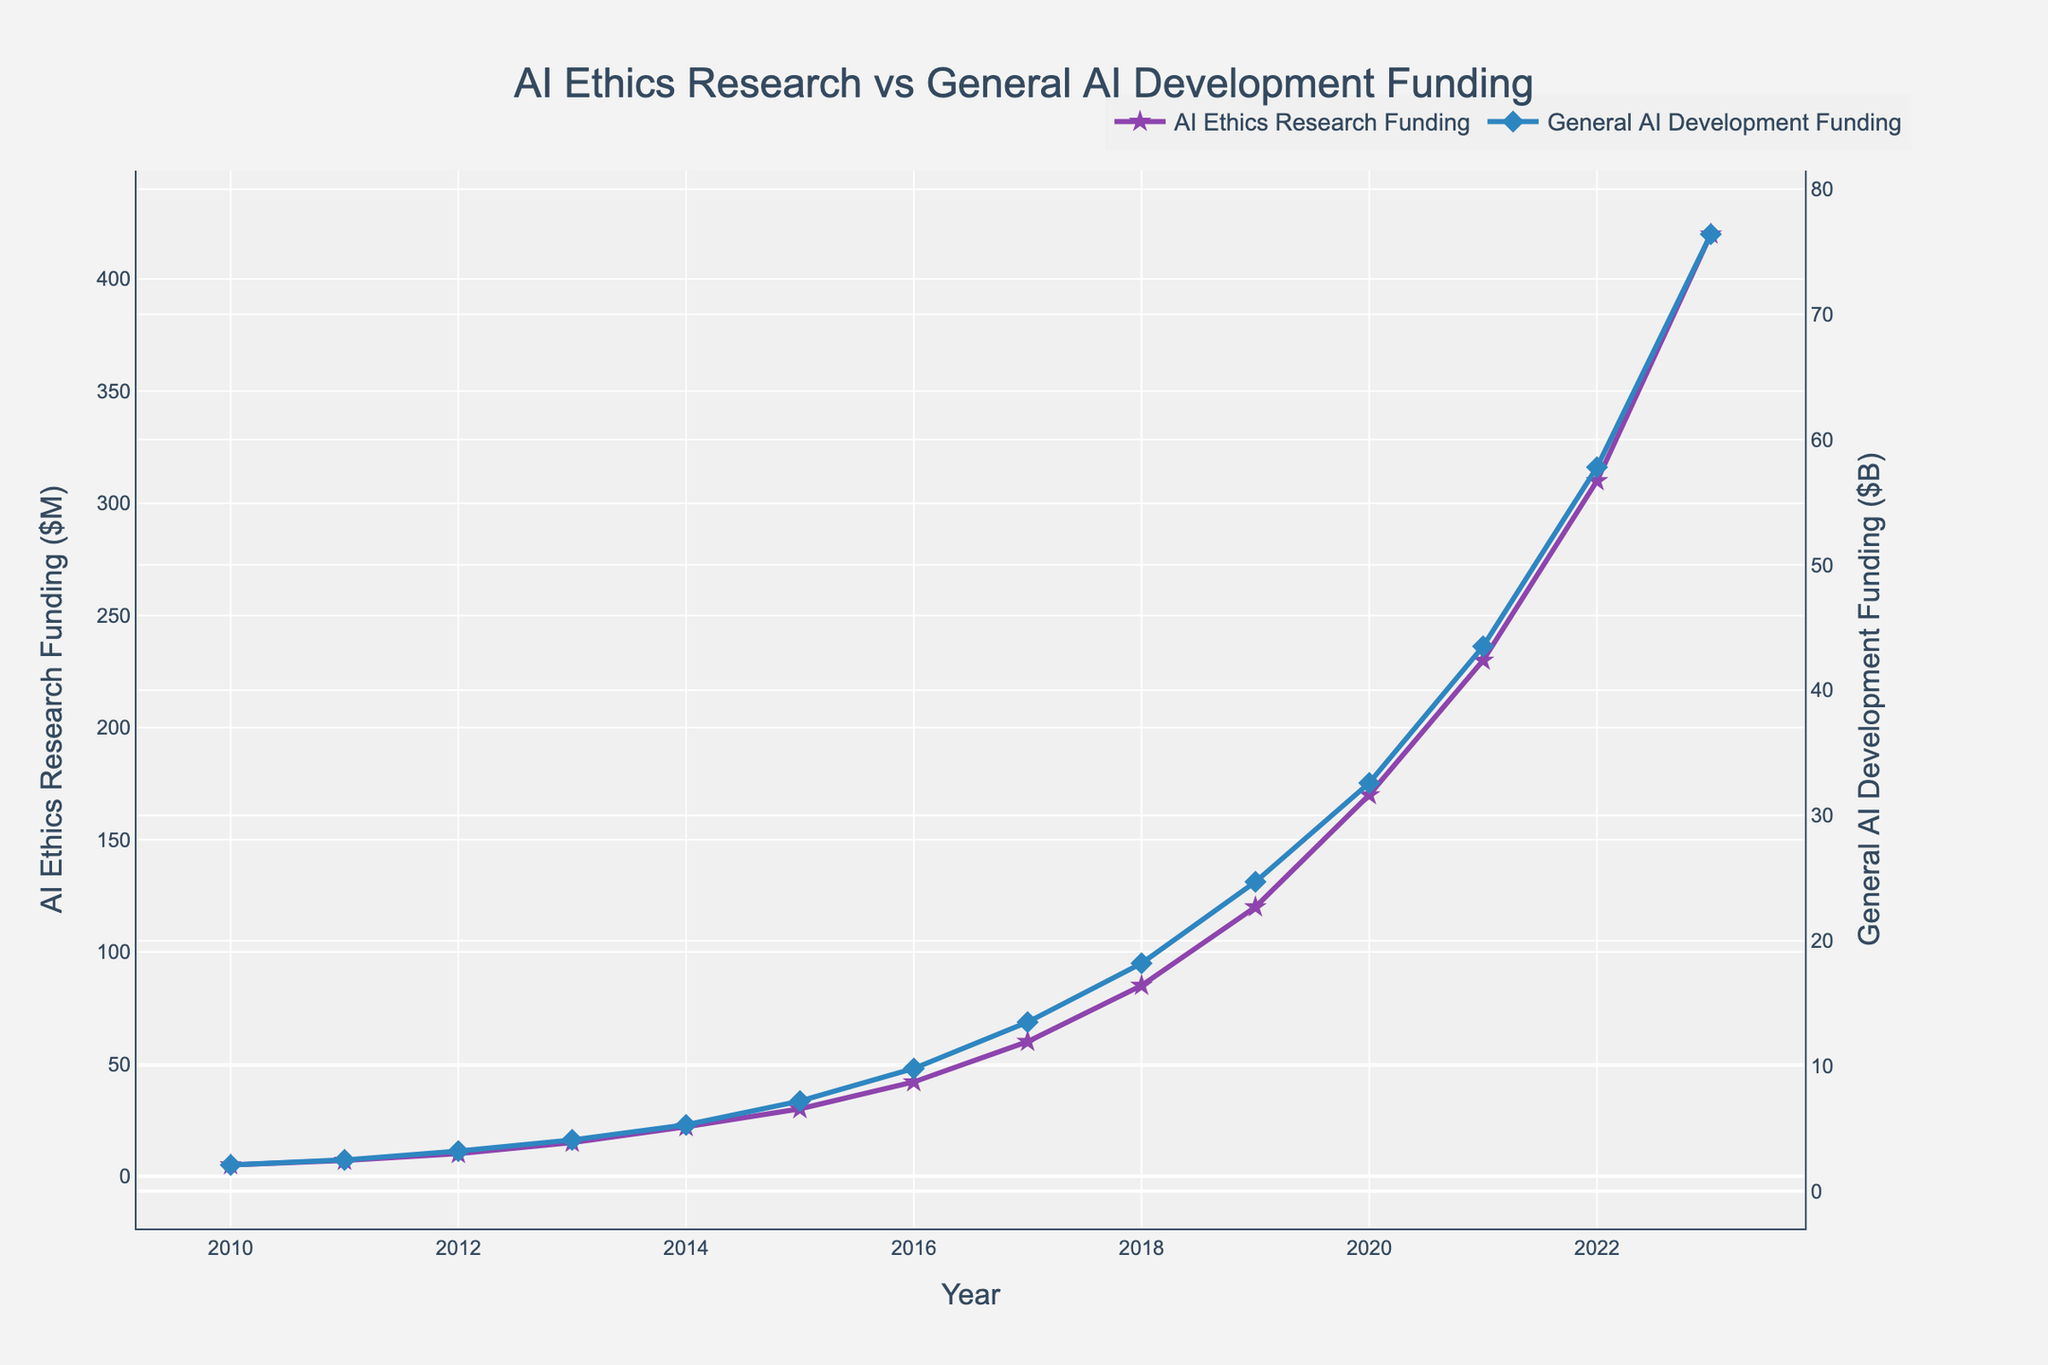Is the trend of funding for AI Ethics Research increasing or decreasing over time? To answer this question, observe the line representing AI Ethics Research Funding. It continually rises from 2010 to 2023, indicating an increasing trend.
Answer: Increasing In which year did the General AI Development Funding exceed $20B? Look at the line for General AI Development Funding. It exceeds $20B in the year 2019, indicated by the point above the $20B mark on the secondary y-axis.
Answer: 2019 What is the difference in funding between AI Ethics Research and General AI Development in 2023? For 2023, AI Ethics Research Funding is $420M, and General AI Development Funding is $76.4B. To find the difference, convert both to the same unit, then subtract: $76.4B = $76400M, so $76400M - $420M = $75980M.
Answer: $75980M Compare the growth rate of AI Ethics Research Funding between 2010-2015 and 2015-2020. First, compute the changes for both periods. From 2010 to 2015, AI Ethics Research Funding goes from $5M to $30M, a $25M increase over 5 years. From 2015 to 2020, it goes from $30M to $170M, a $140M increase over 5 years. Compare the increments to determine that the growth rate was faster between 2015 and 2020.
Answer: Faster between 2015-2020 What is the visual difference between the markers used for AI Ethics Research Funding and General AI Development Funding? Visually, AI Ethics Research Funding markers are represented by stars, whereas General AI Development Funding markers are represented by diamonds.
Answer: Stars vs Diamonds Which year shows the sharpest increase in AI Ethics Research Funding? Observe the slope of the AI Ethics Research Funding curve. The sharpest increase appears between 2022 and 2023, where the funding rises steeply.
Answer: 2022-2023 How does the trend in General AI Development Funding compare to AI Ethics Research Funding over the entire period? Both funding trends increase over time; however, General AI Development Funding rises more steeply compared to AI Ethics Research Funding, indicating higher absolute increases each year.
Answer: Steeper increase for General AI Development In 2015, how many times greater was General AI Development Funding compared to AI Ethics Research Funding? In 2015, AI Ethics Research Funding was $30M, and General AI Development Funding was $7.2B, which is $7200M. The comparison is $7200M / $30M = 240.
Answer: 240 times What is the color associated with the line representing General AI Development Funding? The line for General AI Development Funding is blue in color, as represented visually on the chart.
Answer: Blue 